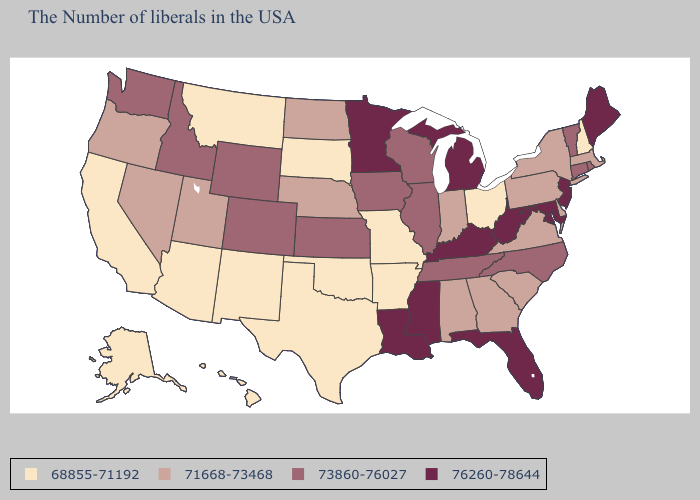Which states have the highest value in the USA?
Short answer required. Maine, New Jersey, Maryland, West Virginia, Florida, Michigan, Kentucky, Mississippi, Louisiana, Minnesota. What is the lowest value in the Northeast?
Quick response, please. 68855-71192. Name the states that have a value in the range 71668-73468?
Write a very short answer. Massachusetts, New York, Delaware, Pennsylvania, Virginia, South Carolina, Georgia, Indiana, Alabama, Nebraska, North Dakota, Utah, Nevada, Oregon. What is the value of New Mexico?
Keep it brief. 68855-71192. Does the map have missing data?
Keep it brief. No. What is the value of Tennessee?
Quick response, please. 73860-76027. What is the value of New York?
Keep it brief. 71668-73468. Name the states that have a value in the range 73860-76027?
Answer briefly. Rhode Island, Vermont, Connecticut, North Carolina, Tennessee, Wisconsin, Illinois, Iowa, Kansas, Wyoming, Colorado, Idaho, Washington. What is the lowest value in the South?
Write a very short answer. 68855-71192. Name the states that have a value in the range 76260-78644?
Write a very short answer. Maine, New Jersey, Maryland, West Virginia, Florida, Michigan, Kentucky, Mississippi, Louisiana, Minnesota. What is the lowest value in the USA?
Be succinct. 68855-71192. What is the value of Arkansas?
Be succinct. 68855-71192. Which states have the lowest value in the MidWest?
Quick response, please. Ohio, Missouri, South Dakota. What is the value of South Carolina?
Concise answer only. 71668-73468. Which states have the lowest value in the Northeast?
Answer briefly. New Hampshire. 